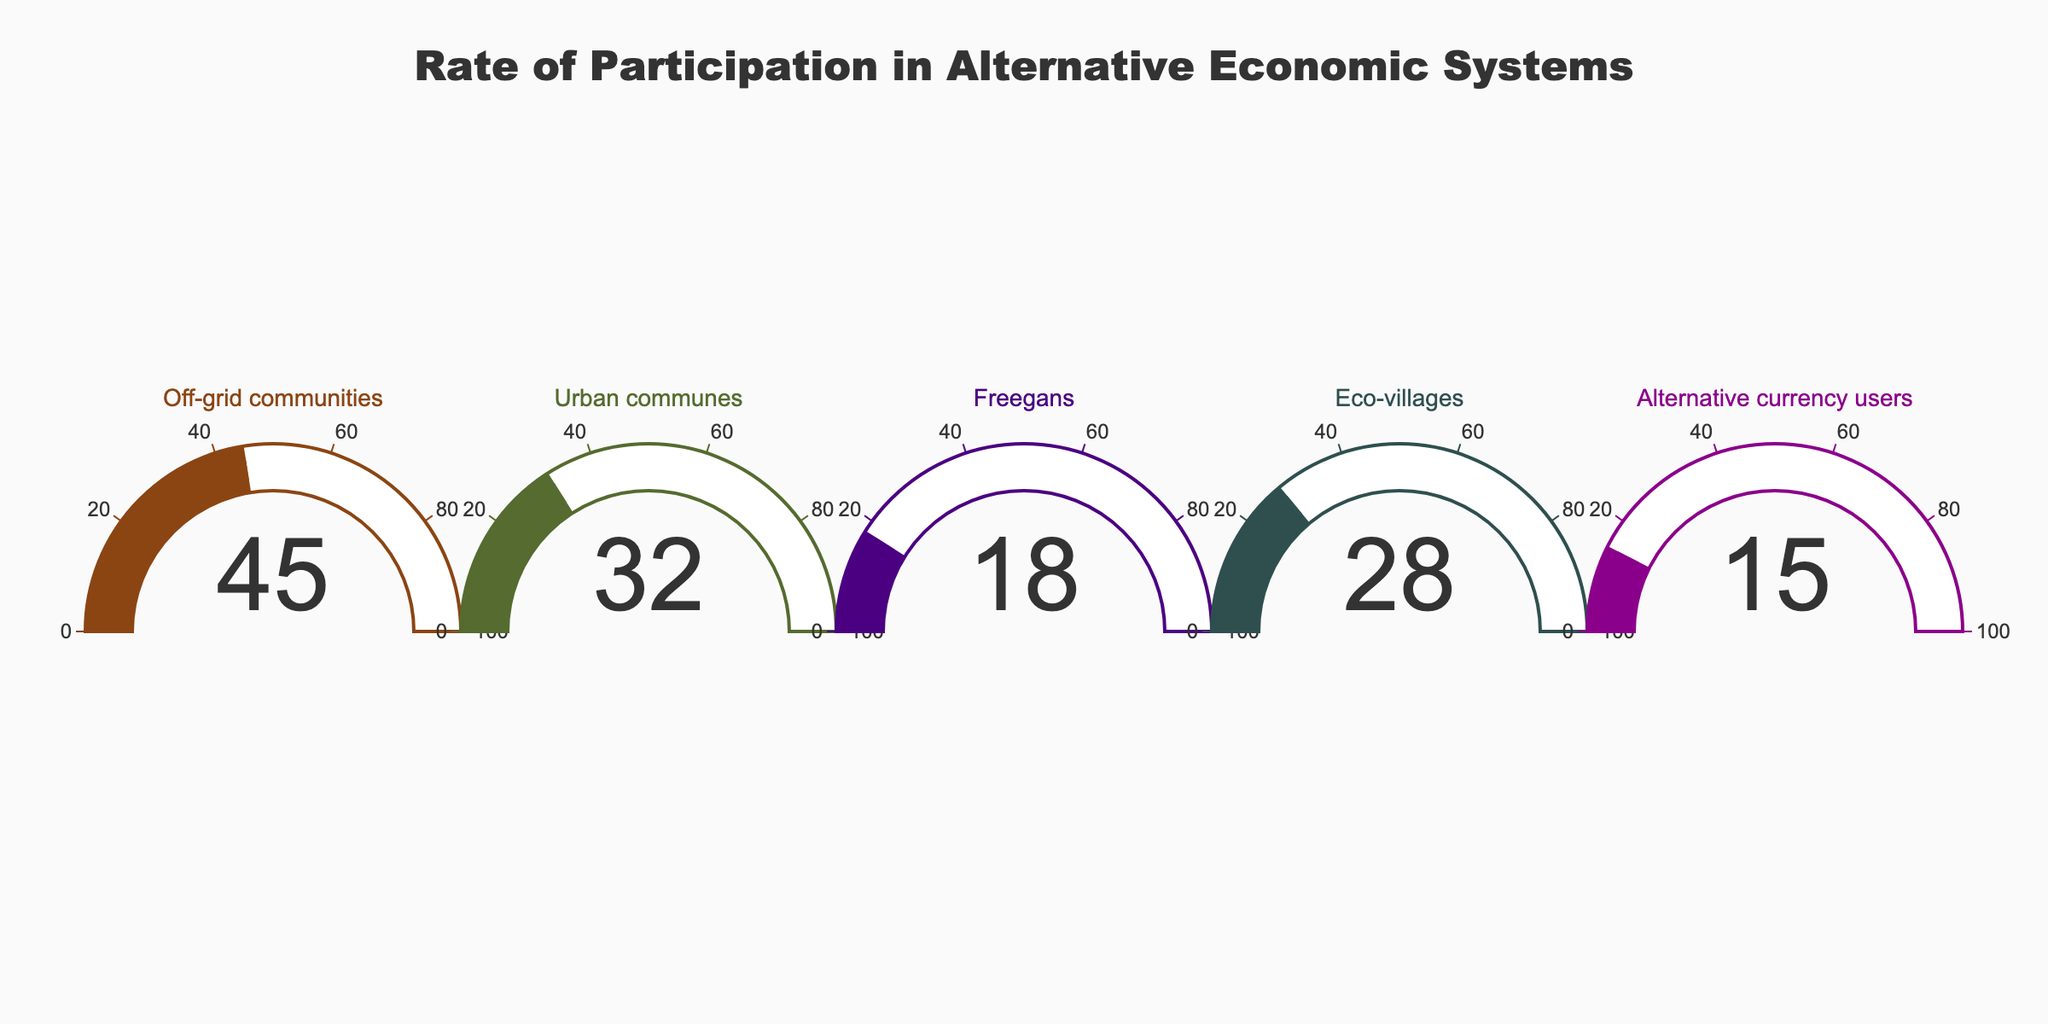What is the title of the figure? The title is displayed at the top of the figure. It is written in larger text to indicate what the gauges represent.
Answer: Rate of Participation in Alternative Economic Systems How many categories are displayed on the gauge chart? The figure shows a separate gauge for each category. Count the number of distinct categories or sections.
Answer: 5 Which category has the highest rate of participation? Look at the gauge with the highest percentage value to determine which category it corresponds to.
Answer: Off-grid communities What is the percentage of participation in urban communes? Find the gauge labeled 'Urban communes' and read the numerical value displayed on it.
Answer: 32% Calculate the average participation rate across all the categories. Add the percentage values of all categories and divide by the number of categories: (45 + 32 + 18 + 28 + 15) / 5 = 138 / 5 = 27.6
Answer: 27.6% What is the difference in participation rates between Freegans and Eco-villages? Subtract the value of the 'Freegans' gauge from the value of the 'Eco-villages' gauge: 28 - 18 = 10
Answer: 10 Which category has the lowest rate of participation? Look at the gauge with the lowest percentage value to determine which category it corresponds to.
Answer: Alternative currency users Compare the participation rates of Off-grid communities and Urban communes. Compare the values of the corresponding gauges: Off-grid communities (45%) and Urban communes (32%). Since 45% > 32%, Off-grid communities have a higher participation rate.
Answer: Off-grid communities What colors are used in the figure for the gauges? Refer to the color of the gauge bars or frames for each category. Identify and list down the colors used.
Answer: Brown, dark green, indigo, dark slate gray, dark magenta Are there any categories with a participation rate below 20%? If yes, which ones? Check the values on the gauges to see if any are below 20%.
Answer: Yes, Freegans (18%) and Alternative currency users (15%) 